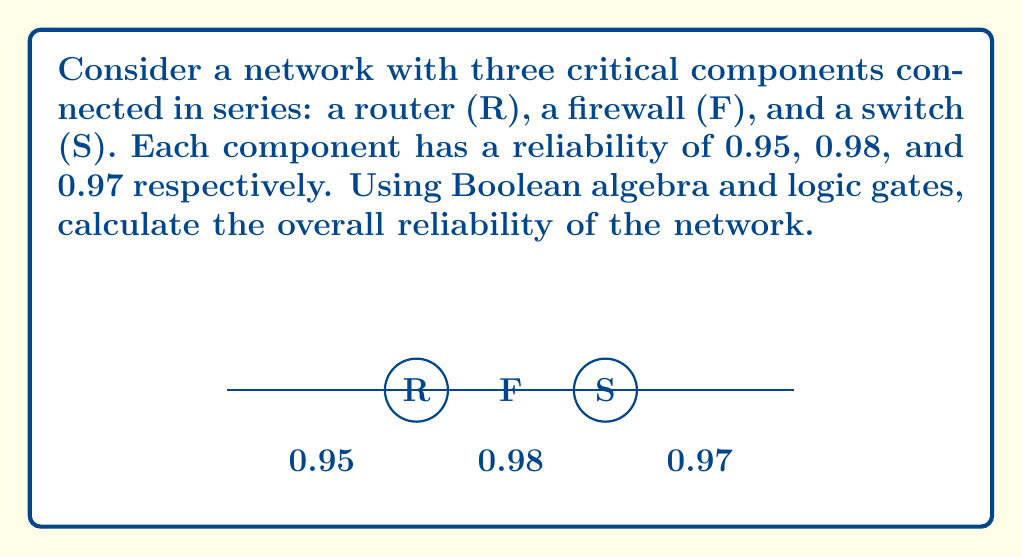Solve this math problem. To solve this problem, we'll use Boolean algebra and the concept of series reliability.

Step 1: Represent each component's reliability as a probability.
R = 0.95
F = 0.98
S = 0.97

Step 2: In a series configuration, all components must work for the system to function. This is equivalent to the logical AND operation. The probability of all components working is the product of their individual reliabilities.

Step 3: Express the overall reliability using Boolean algebra:
$$P(\text{system works}) = P(R \text{ AND } F \text{ AND } S) = P(R) \cdot P(F) \cdot P(S)$$

Step 4: Calculate the overall reliability:
$$P(\text{system works}) = 0.95 \cdot 0.98 \cdot 0.97$$

Step 5: Perform the multiplication:
$$P(\text{system works}) = 0.9016$$

Therefore, the overall reliability of the network is approximately 0.9016 or 90.16%.
Answer: 0.9016 